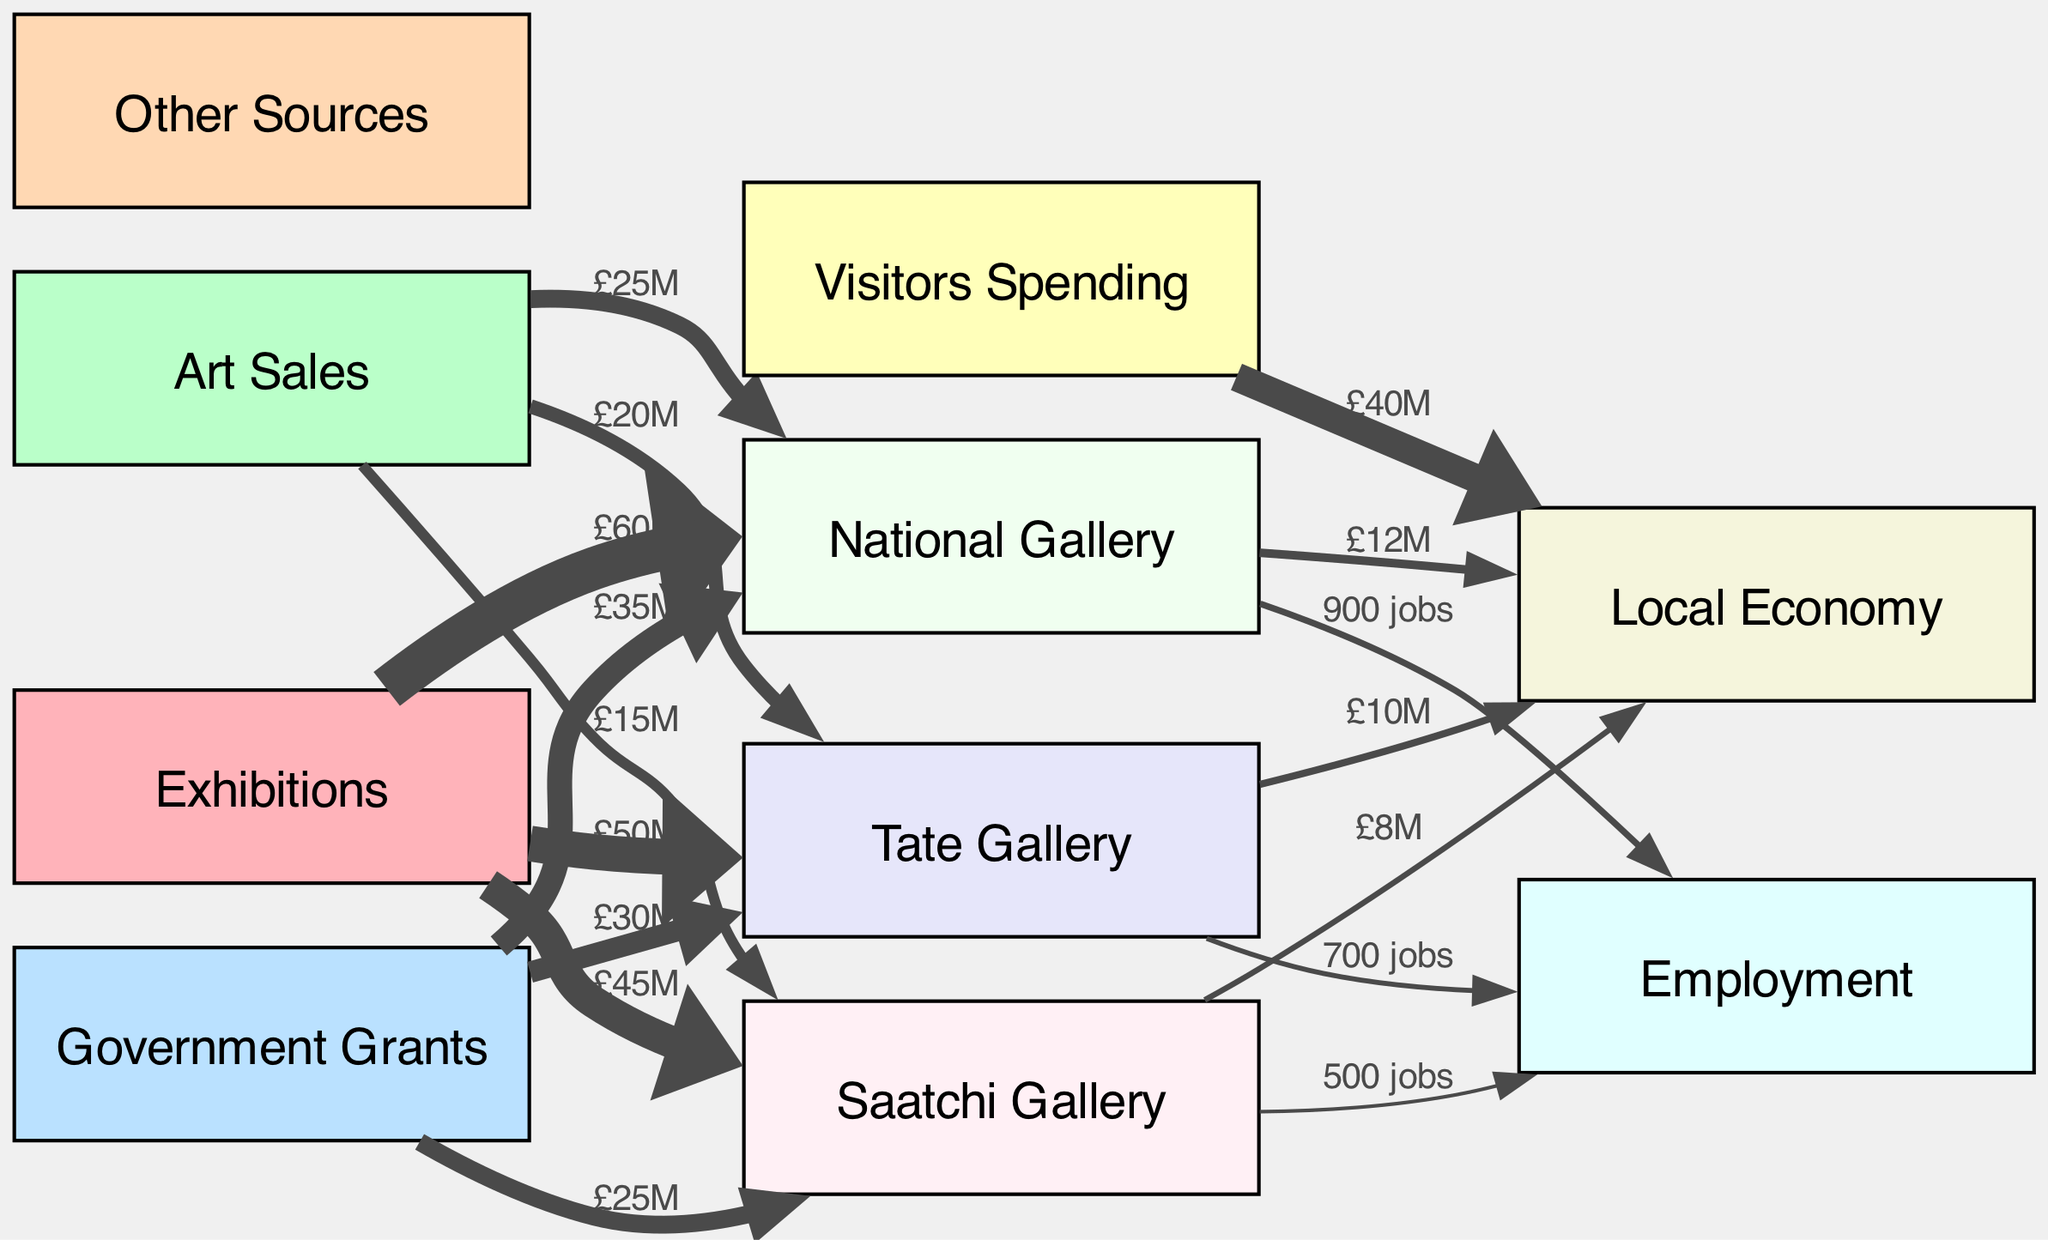What is the total revenue from exhibitions at the National Gallery? The diagram indicates that the revenue from exhibitions at the National Gallery is £60M, clearly stated in the edge connecting "exhibitions" to "national_gallery."
Answer: £60M How much revenue does the Saatchi Gallery receive from government grants? The value associated with government grants for the Saatchi Gallery, as depicted in the diagram, is £25M, which is shown in the edge from "grants" to "saatchi_gallery."
Answer: £25M How much do visitors spend in total on the local economy? The diagram shows that visitors spending contributes £40M to the local economy, which is indicated on the edge connecting "visitors_spending" to "local_economy."
Answer: £40M What is the total employment impact of all three galleries combined? By adding the employment values detailed for each gallery: Tate Gallery (700 jobs), National Gallery (900 jobs), and Saatchi Gallery (500 jobs), the total is 700 + 900 + 500 = 2100 jobs.
Answer: 2100 jobs Which gallery has the highest revenue from exhibitions? The edge labels show that the National Gallery has the highest revenue from exhibitions with £60M, which is greater than the £50M from Tate Gallery and £45M from Saatchi Gallery.
Answer: National Gallery How does Tate Gallery's revenue from art sales compare to that of Saatchi Gallery? Tate Gallery has £20M from art sales while Saatchi Gallery has £15M, indicating that Tate Gallery earns more from art sales by £5M.
Answer: £5M more What is the sum of all government grants received by the three galleries? To find this, we add the grants amounts: Tate Gallery (£30M) + National Gallery (£35M) + Saatchi Gallery (£25M) equals £30M + £35M + £25M = £90M.
Answer: £90M Which source contributes the least to the local economy? According to the edges leading to "local_economy", Saatchi Gallery contributes £8M, which is lower than the contributions from Tate Gallery (£10M) and National Gallery (£12M).
Answer: Saatchi Gallery What percentage of the revenue from exhibitions is allocated to employment for the National Gallery? The National Gallery generates £60M from exhibitions and employs 900 people, which translates to 900/60000 = 0.015 or 1.5% of its exhibition revenue is allocated to employment.
Answer: 1.5% 